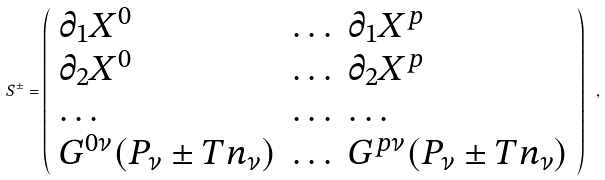<formula> <loc_0><loc_0><loc_500><loc_500>S ^ { \pm } = \left ( \begin{array} { l l l } { { \partial _ { 1 } X ^ { 0 } } } & { \dots } & { { \partial _ { 1 } X ^ { p } } } \\ { { \partial _ { 2 } X ^ { 0 } } } & { \dots } & { { \partial _ { 2 } X ^ { p } } } \\ { \dots } & { \dots } & { \dots } \\ { { G ^ { 0 \nu } ( P _ { \nu } \pm T n _ { \nu } ) } } & { \dots } & { { G ^ { p \nu } ( P _ { \nu } \pm T n _ { \nu } ) } } \end{array} \right ) \ ,</formula> 